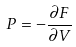<formula> <loc_0><loc_0><loc_500><loc_500>P = - \frac { \partial F } { \partial V }</formula> 